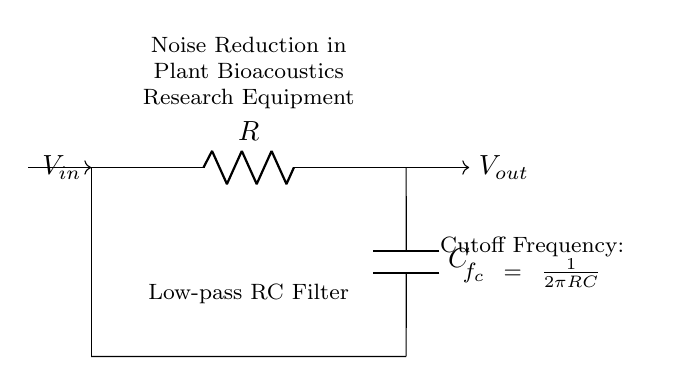What components are present in this circuit? The circuit includes a resistor and a capacitor, which are the essential components of an RC filter.
Answer: Resistor and Capacitor What is the function of the circuit? The circuit functions as a low-pass filter, allowing low-frequency signals to pass while attenuating higher frequencies, which is particularly useful for reducing noise in bioacoustics equipment.
Answer: Low-pass filter What is the cutoff frequency formula for this circuit? The cutoff frequency is defined by the formula \( f_c = \frac{1}{2\pi RC} \), showing the relationship between the resistor and capacitor values in determining the frequency at which the output starts to decrease.
Answer: f_c = 1/(2πRC) How would increasing the resistance affect the cutoff frequency? Increasing the resistance \( R \) will decrease the cutoff frequency \( f_c \) since they are inversely proportional in the formula. This means lower frequencies will be allowed to pass through the filter.
Answer: Decreases cutoff frequency What type of filter is represented by this RC circuit? This circuit is specifically a low-pass filter, indicating that it is designed to permit signals below a certain frequency while blocking higher frequencies, useful in various signal processing applications.
Answer: Low-pass filter In what context might this RC filter be used? This RC filter could be used in plant bioacoustics research equipment to minimize electrical noise, thereby enhancing the clarity of the sound signals being recorded for analysis of plant communication or responses.
Answer: Plant bioacoustics research 